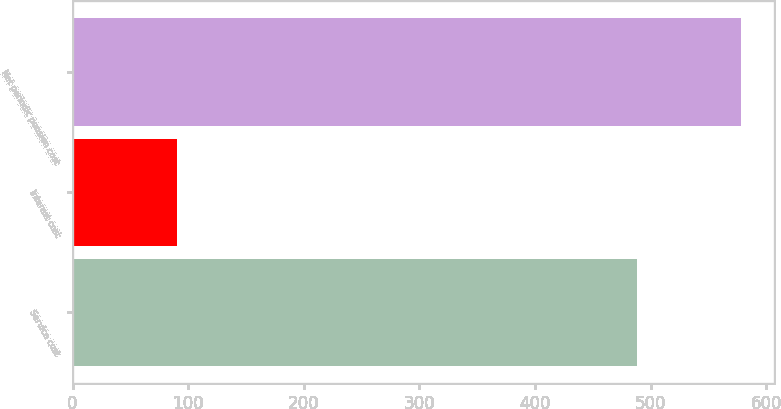Convert chart to OTSL. <chart><loc_0><loc_0><loc_500><loc_500><bar_chart><fcel>Service cost<fcel>Interest cost<fcel>Net periodic pension cost<nl><fcel>488<fcel>90<fcel>578<nl></chart> 